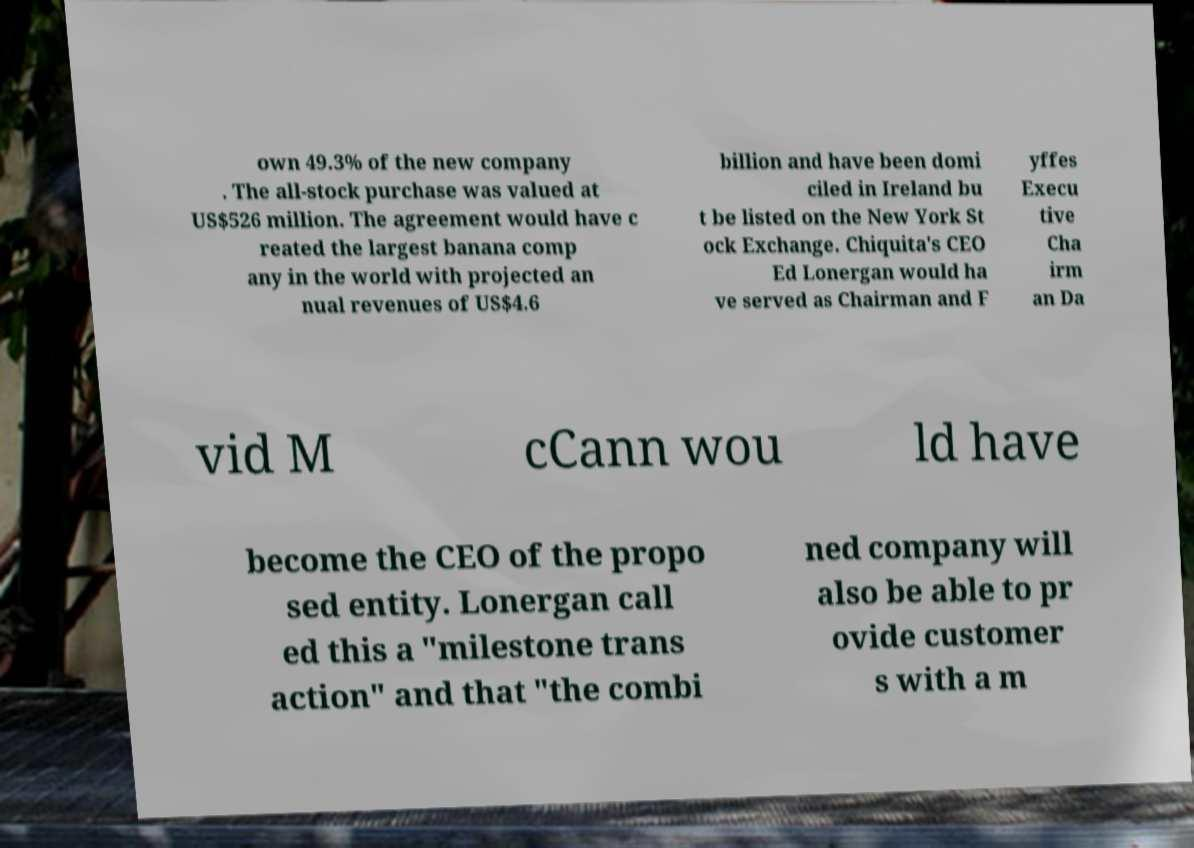Could you assist in decoding the text presented in this image and type it out clearly? own 49.3% of the new company . The all-stock purchase was valued at US$526 million. The agreement would have c reated the largest banana comp any in the world with projected an nual revenues of US$4.6 billion and have been domi ciled in Ireland bu t be listed on the New York St ock Exchange. Chiquita's CEO Ed Lonergan would ha ve served as Chairman and F yffes Execu tive Cha irm an Da vid M cCann wou ld have become the CEO of the propo sed entity. Lonergan call ed this a "milestone trans action" and that "the combi ned company will also be able to pr ovide customer s with a m 